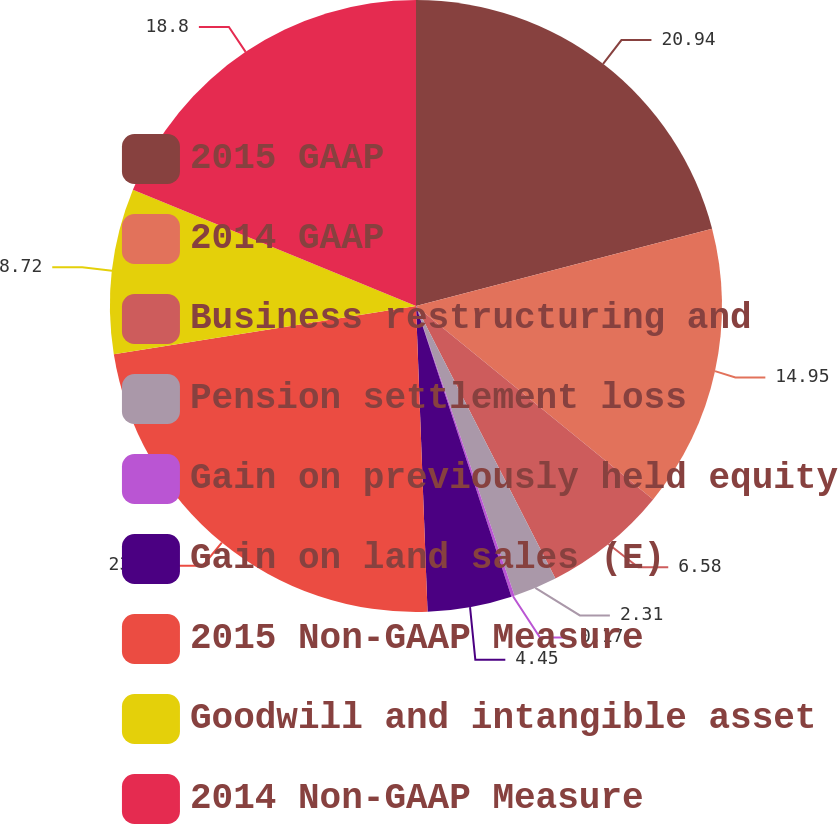Convert chart to OTSL. <chart><loc_0><loc_0><loc_500><loc_500><pie_chart><fcel>2015 GAAP<fcel>2014 GAAP<fcel>Business restructuring and<fcel>Pension settlement loss<fcel>Gain on previously held equity<fcel>Gain on land sales (E)<fcel>2015 Non-GAAP Measure<fcel>Goodwill and intangible asset<fcel>2014 Non-GAAP Measure<nl><fcel>20.94%<fcel>14.95%<fcel>6.58%<fcel>2.31%<fcel>0.17%<fcel>4.45%<fcel>23.08%<fcel>8.72%<fcel>18.8%<nl></chart> 